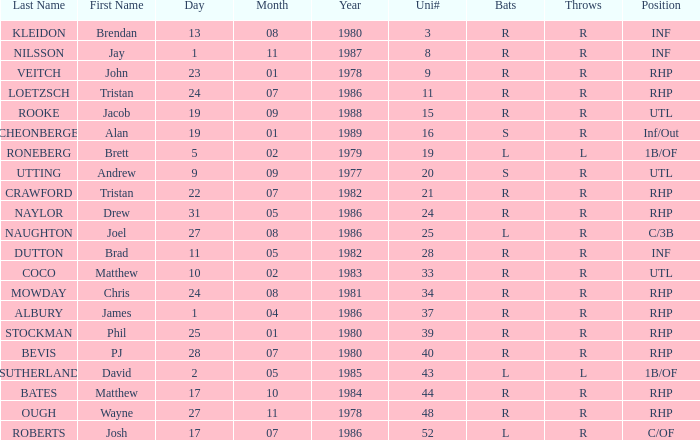Which surname features throws of l, and a dob of 5/02/79? RONEBERG. 